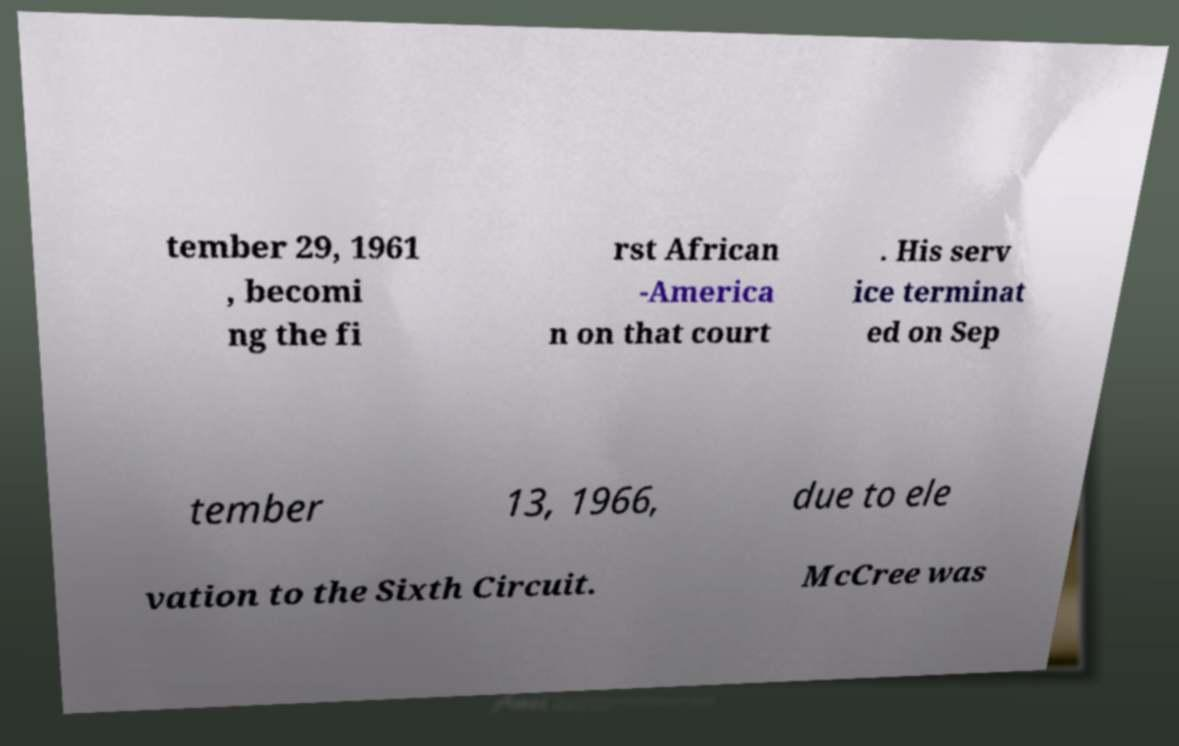For documentation purposes, I need the text within this image transcribed. Could you provide that? tember 29, 1961 , becomi ng the fi rst African -America n on that court . His serv ice terminat ed on Sep tember 13, 1966, due to ele vation to the Sixth Circuit. McCree was 